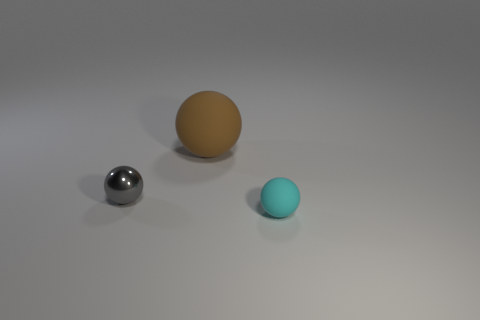Add 1 small cyan matte objects. How many objects exist? 4 Subtract 0 purple blocks. How many objects are left? 3 Subtract all rubber spheres. Subtract all small gray shiny spheres. How many objects are left? 0 Add 1 large balls. How many large balls are left? 2 Add 1 small objects. How many small objects exist? 3 